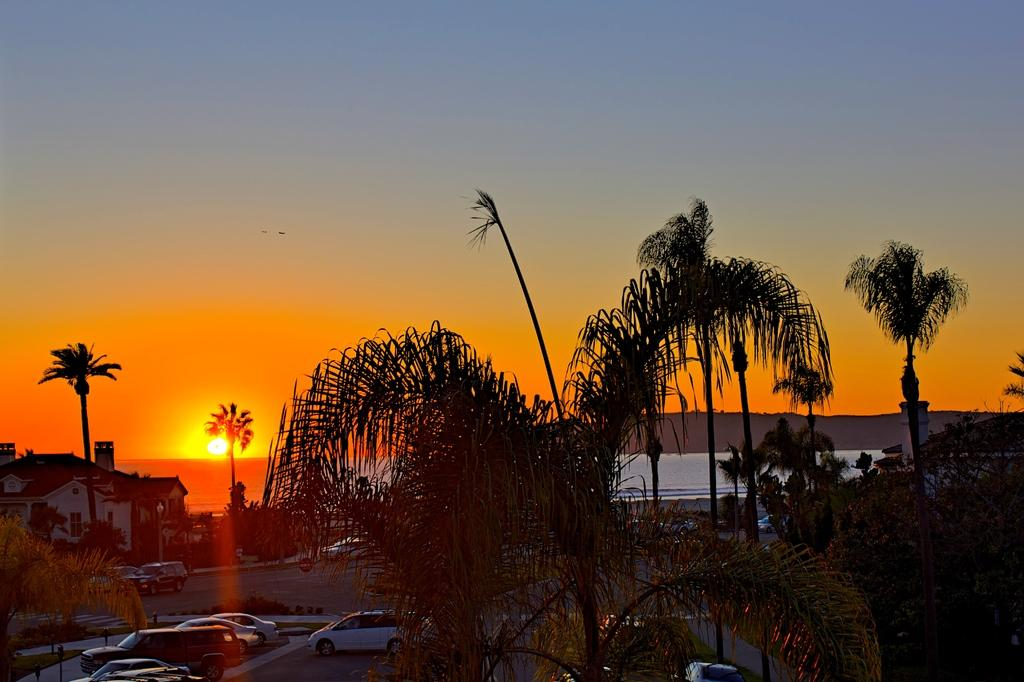What type of vegetation can be seen in the image? There are trees in the image. What type of man-made structures are visible in the image? There are buildings in the image. What can be seen in the background of the image? There are mountains in the background of the image. What is visible at the top of the image? The sun is visible at the top of the image. What type of animals can be seen in the sky? There are birds in the sky. Can you tell me how many dinosaurs are walking on the mountains in the image? There are no dinosaurs present in the image; it features trees, buildings, mountains, the sun, and birds. What type of ear is visible on the buildings in the image? There are no ears present on the buildings in the image; they are architectural structures with no visible ears. 